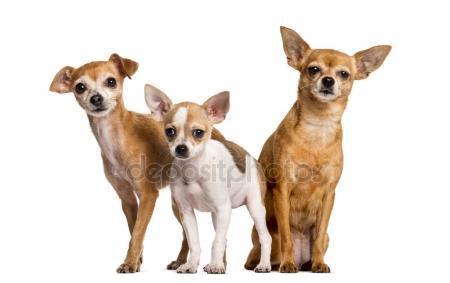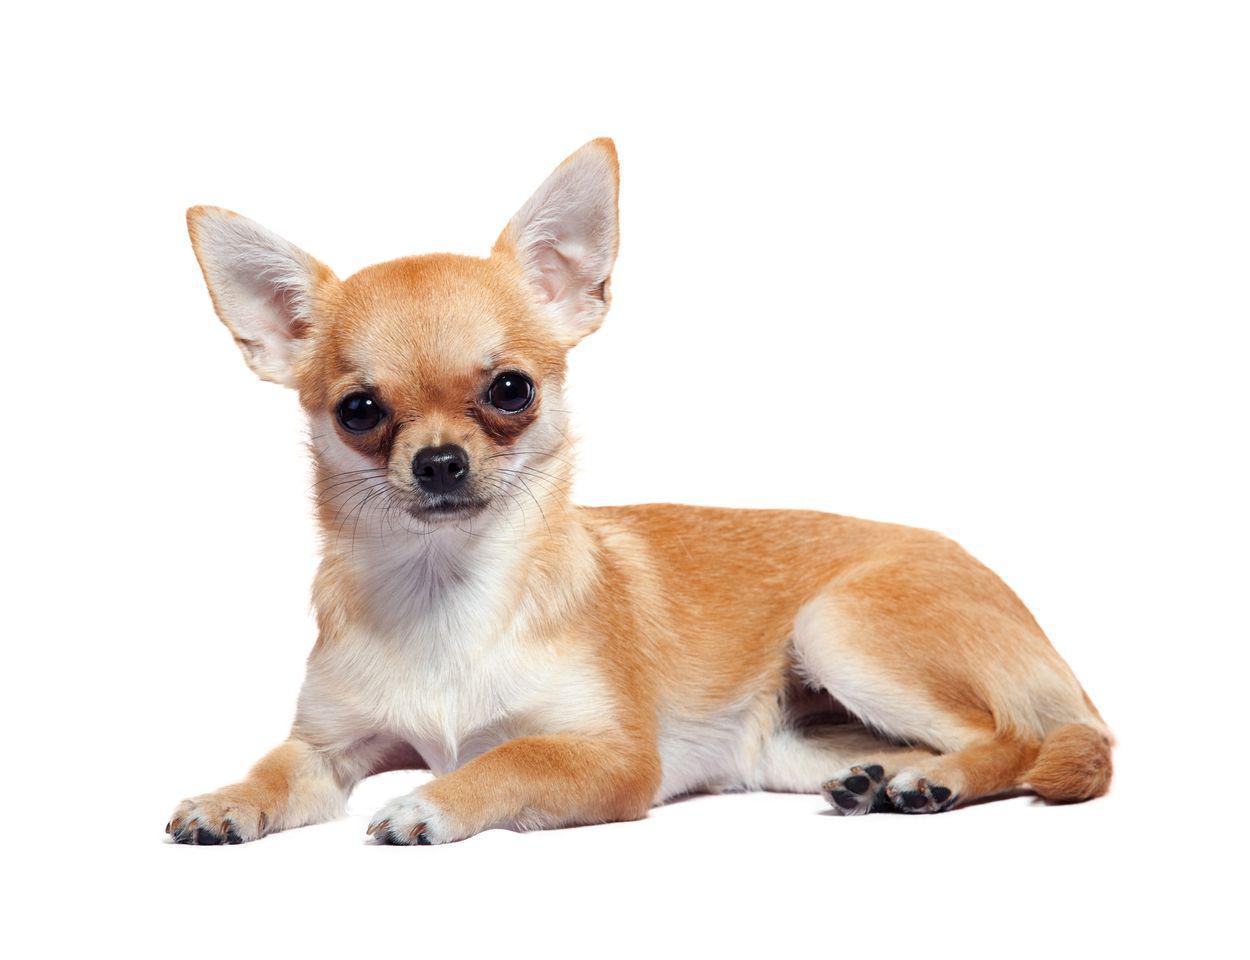The first image is the image on the left, the second image is the image on the right. Evaluate the accuracy of this statement regarding the images: "The right image contains three chihuahua's.". Is it true? Answer yes or no. No. The first image is the image on the left, the second image is the image on the right. Assess this claim about the two images: "There is a single dog in the image on the right.". Correct or not? Answer yes or no. Yes. 